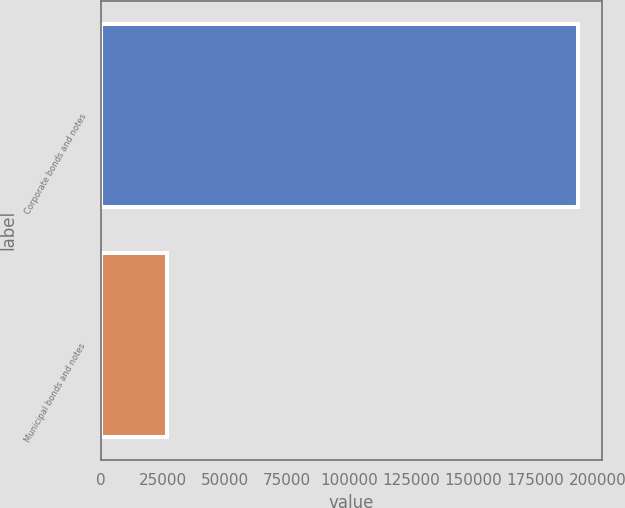<chart> <loc_0><loc_0><loc_500><loc_500><bar_chart><fcel>Corporate bonds and notes<fcel>Municipal bonds and notes<nl><fcel>192278<fcel>26639<nl></chart> 